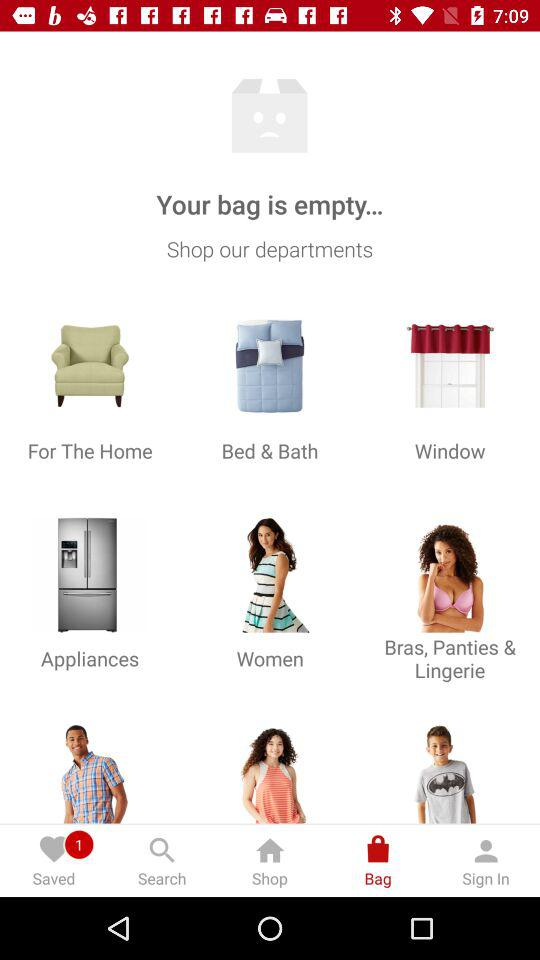How many items are in the shopping bag?
Answer the question using a single word or phrase. 0 